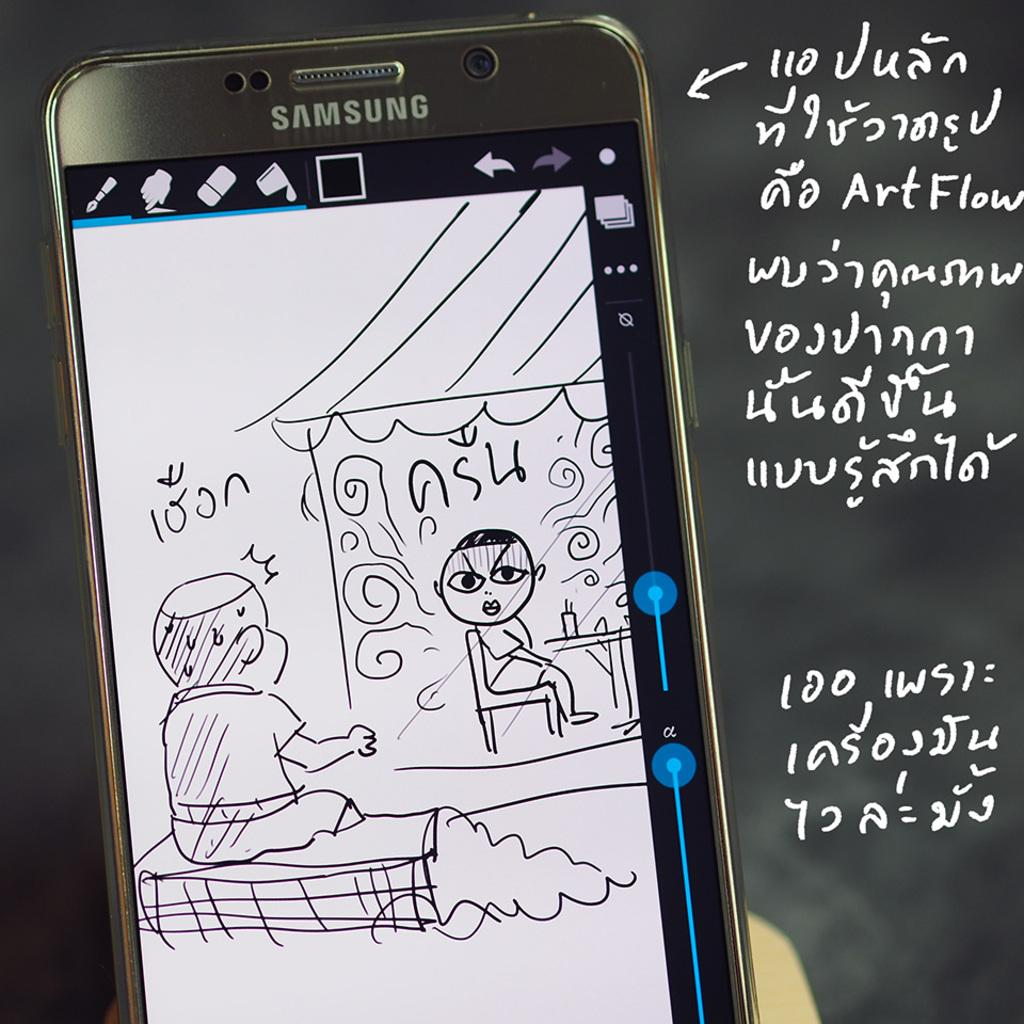Provide a one-sentence caption for the provided image. a drawing of a boy that says 100n on it. 